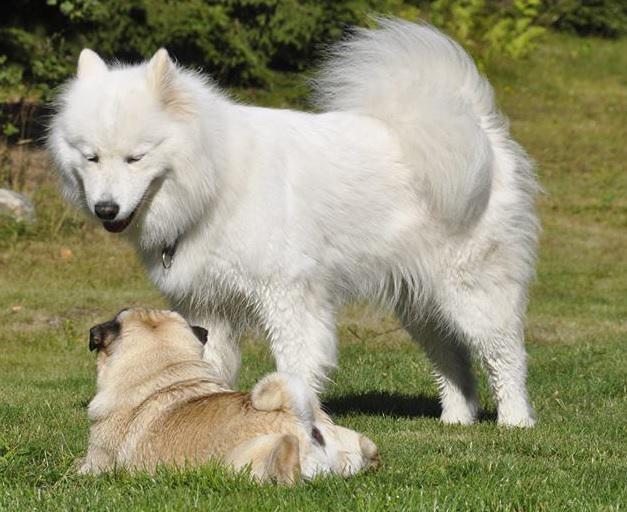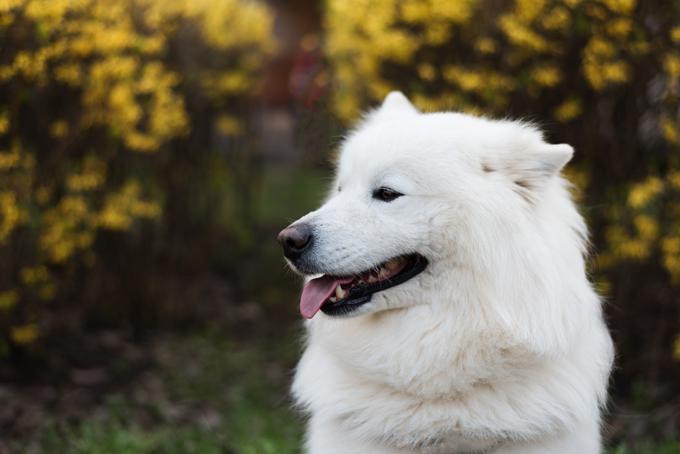The first image is the image on the left, the second image is the image on the right. Evaluate the accuracy of this statement regarding the images: "One of the images has exactly one dog.". Is it true? Answer yes or no. Yes. The first image is the image on the left, the second image is the image on the right. For the images shown, is this caption "There are three dogs" true? Answer yes or no. Yes. 